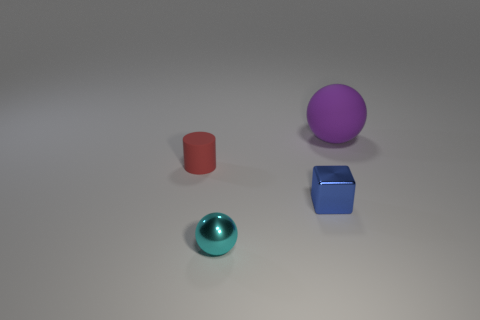Add 2 tiny gray matte spheres. How many objects exist? 6 Subtract 0 cyan cylinders. How many objects are left? 4 Subtract all tiny rubber cylinders. Subtract all cyan metallic spheres. How many objects are left? 2 Add 4 red objects. How many red objects are left? 5 Add 3 big green balls. How many big green balls exist? 3 